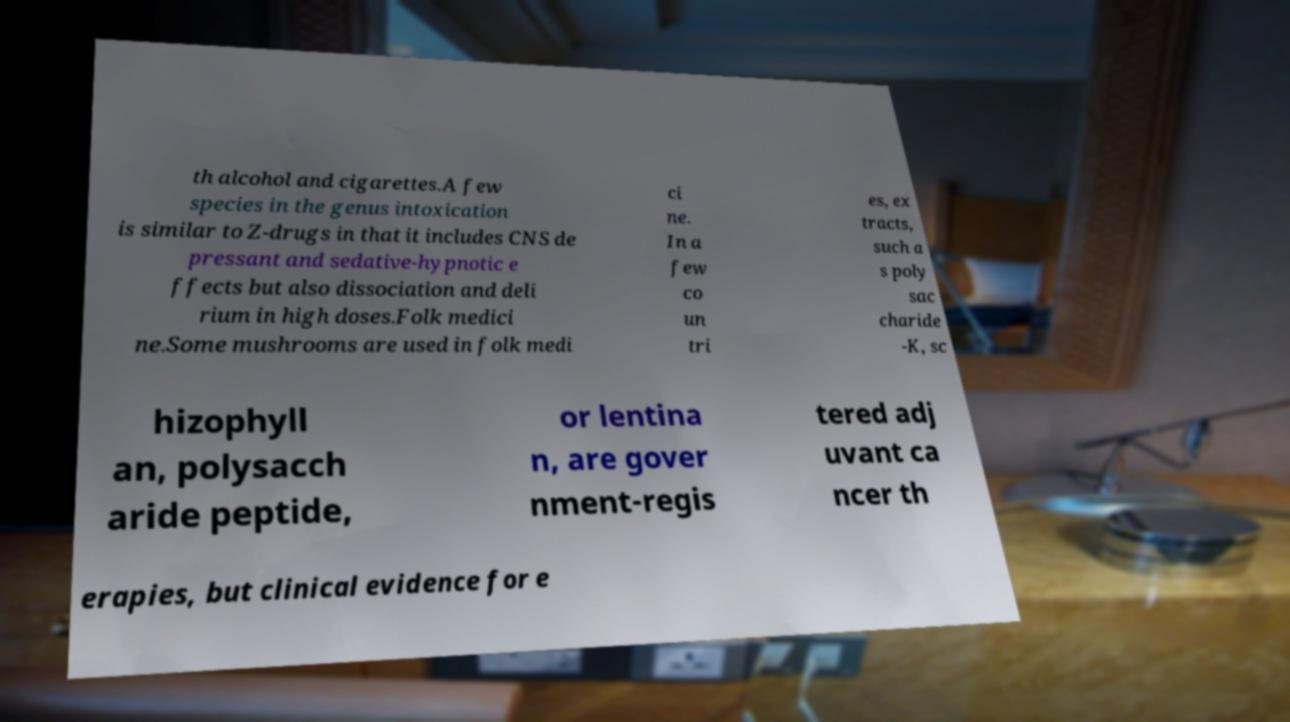Could you assist in decoding the text presented in this image and type it out clearly? th alcohol and cigarettes.A few species in the genus intoxication is similar to Z-drugs in that it includes CNS de pressant and sedative-hypnotic e ffects but also dissociation and deli rium in high doses.Folk medici ne.Some mushrooms are used in folk medi ci ne. In a few co un tri es, ex tracts, such a s poly sac charide -K, sc hizophyll an, polysacch aride peptide, or lentina n, are gover nment-regis tered adj uvant ca ncer th erapies, but clinical evidence for e 